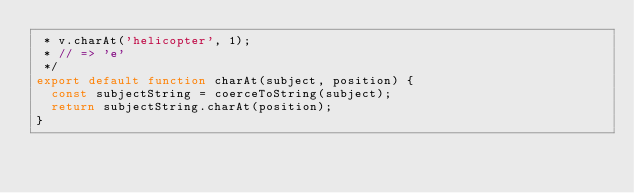Convert code to text. <code><loc_0><loc_0><loc_500><loc_500><_JavaScript_> * v.charAt('helicopter', 1);
 * // => 'e'
 */
export default function charAt(subject, position) {
  const subjectString = coerceToString(subject);
  return subjectString.charAt(position);
}
</code> 